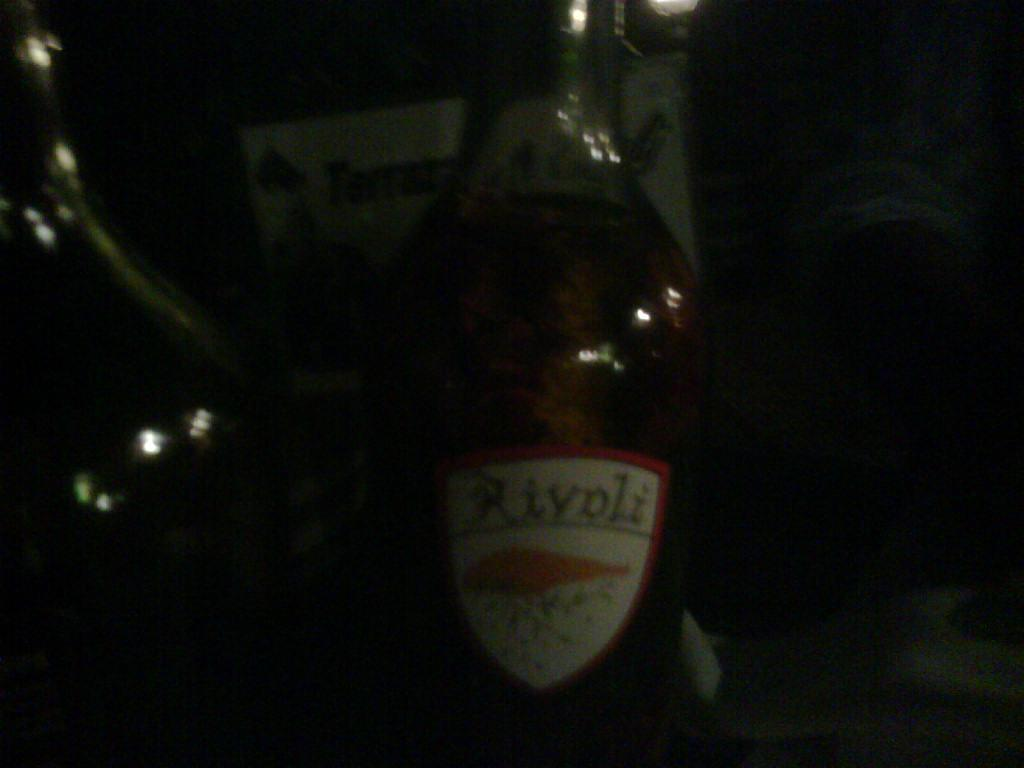What object can be seen in the image? There is a bottle in the image. What is unique about the bottle? The bottle has a sticker on it. Are there any other bottles in the image? Yes, there is another bottle beside the first bottle. How does the plough move through the field in the image? There is no plough present in the image; it only features two bottles. 